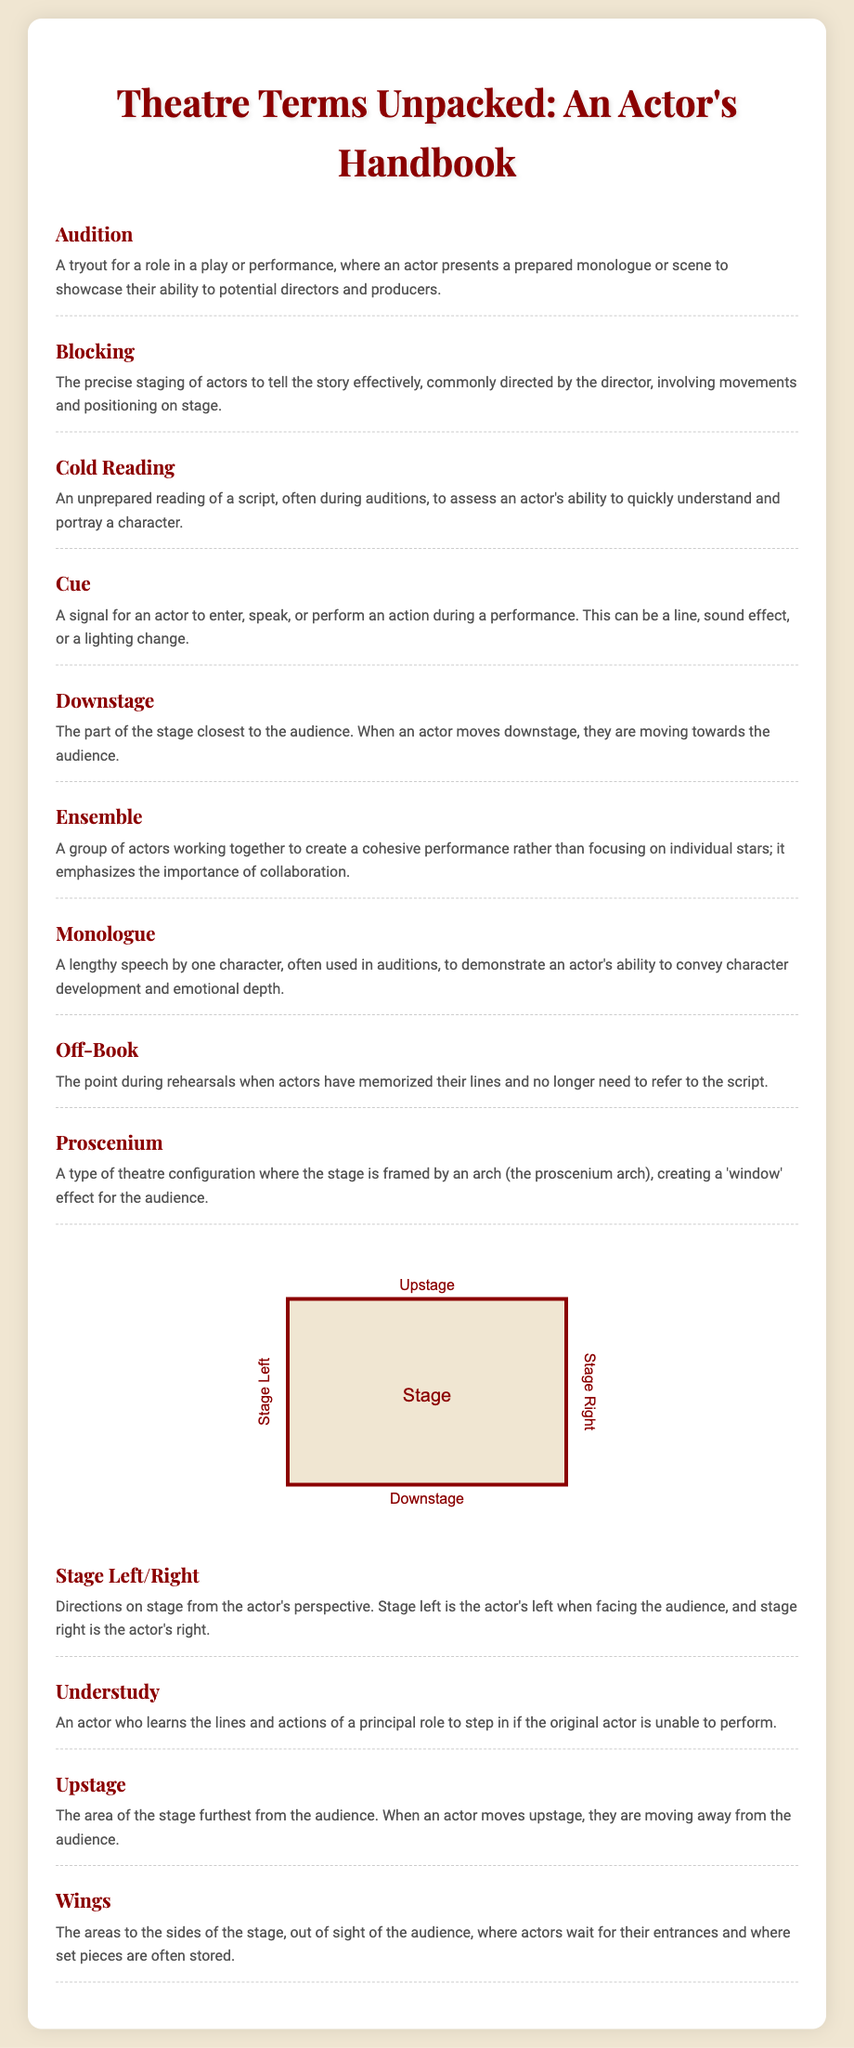What is the term for a tryout for a role? The document defines "Audition" as a tryout for a role in a play or performance.
Answer: Audition What does "Blocking" refer to in theatre? The definition states that "Blocking" is the precise staging of actors to tell the story effectively.
Answer: Precise staging What is a "Monologue"? The document explains "Monologue" as a lengthy speech by one character, often used in auditions.
Answer: Lengthy speech What does an actor do when they are "Off-Book"? According to the glossary, "Off-Book" means that actors have memorized their lines and no longer need the script.
Answer: Memorized lines What area is closest to the audience? The glossary indicates that "Downstage" is the part of the stage closest to the audience.
Answer: Downstage What is the role of an "Understudy"? The document defines "Understudy" as an actor who learns the lines and actions of a principal role to step in if necessary.
Answer: Learn lines What does "Cue" signify in a performance? "Cue" is defined in the document as a signal for an actor to enter, speak, or perform an action.
Answer: Signal How is "Stage Left" determined? The document states that "Stage Left" is the actor's left when facing the audience.
Answer: Actor's left In which theatre configuration is the stage framed by an arch? The glossary describes "Proscenium" as a type of theatre configuration with an arch framing the stage.
Answer: Proscenium 